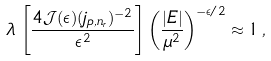<formula> <loc_0><loc_0><loc_500><loc_500>\lambda \, \left [ \frac { 4 { \mathcal { J } } ( \epsilon ) ( j _ { p , n _ { r } } ) ^ { - 2 } } { \epsilon ^ { 2 } } \right ] \left ( \frac { | E | } { \mu ^ { 2 } } \right ) ^ { - \epsilon / 2 } \approx 1 \, ,</formula> 